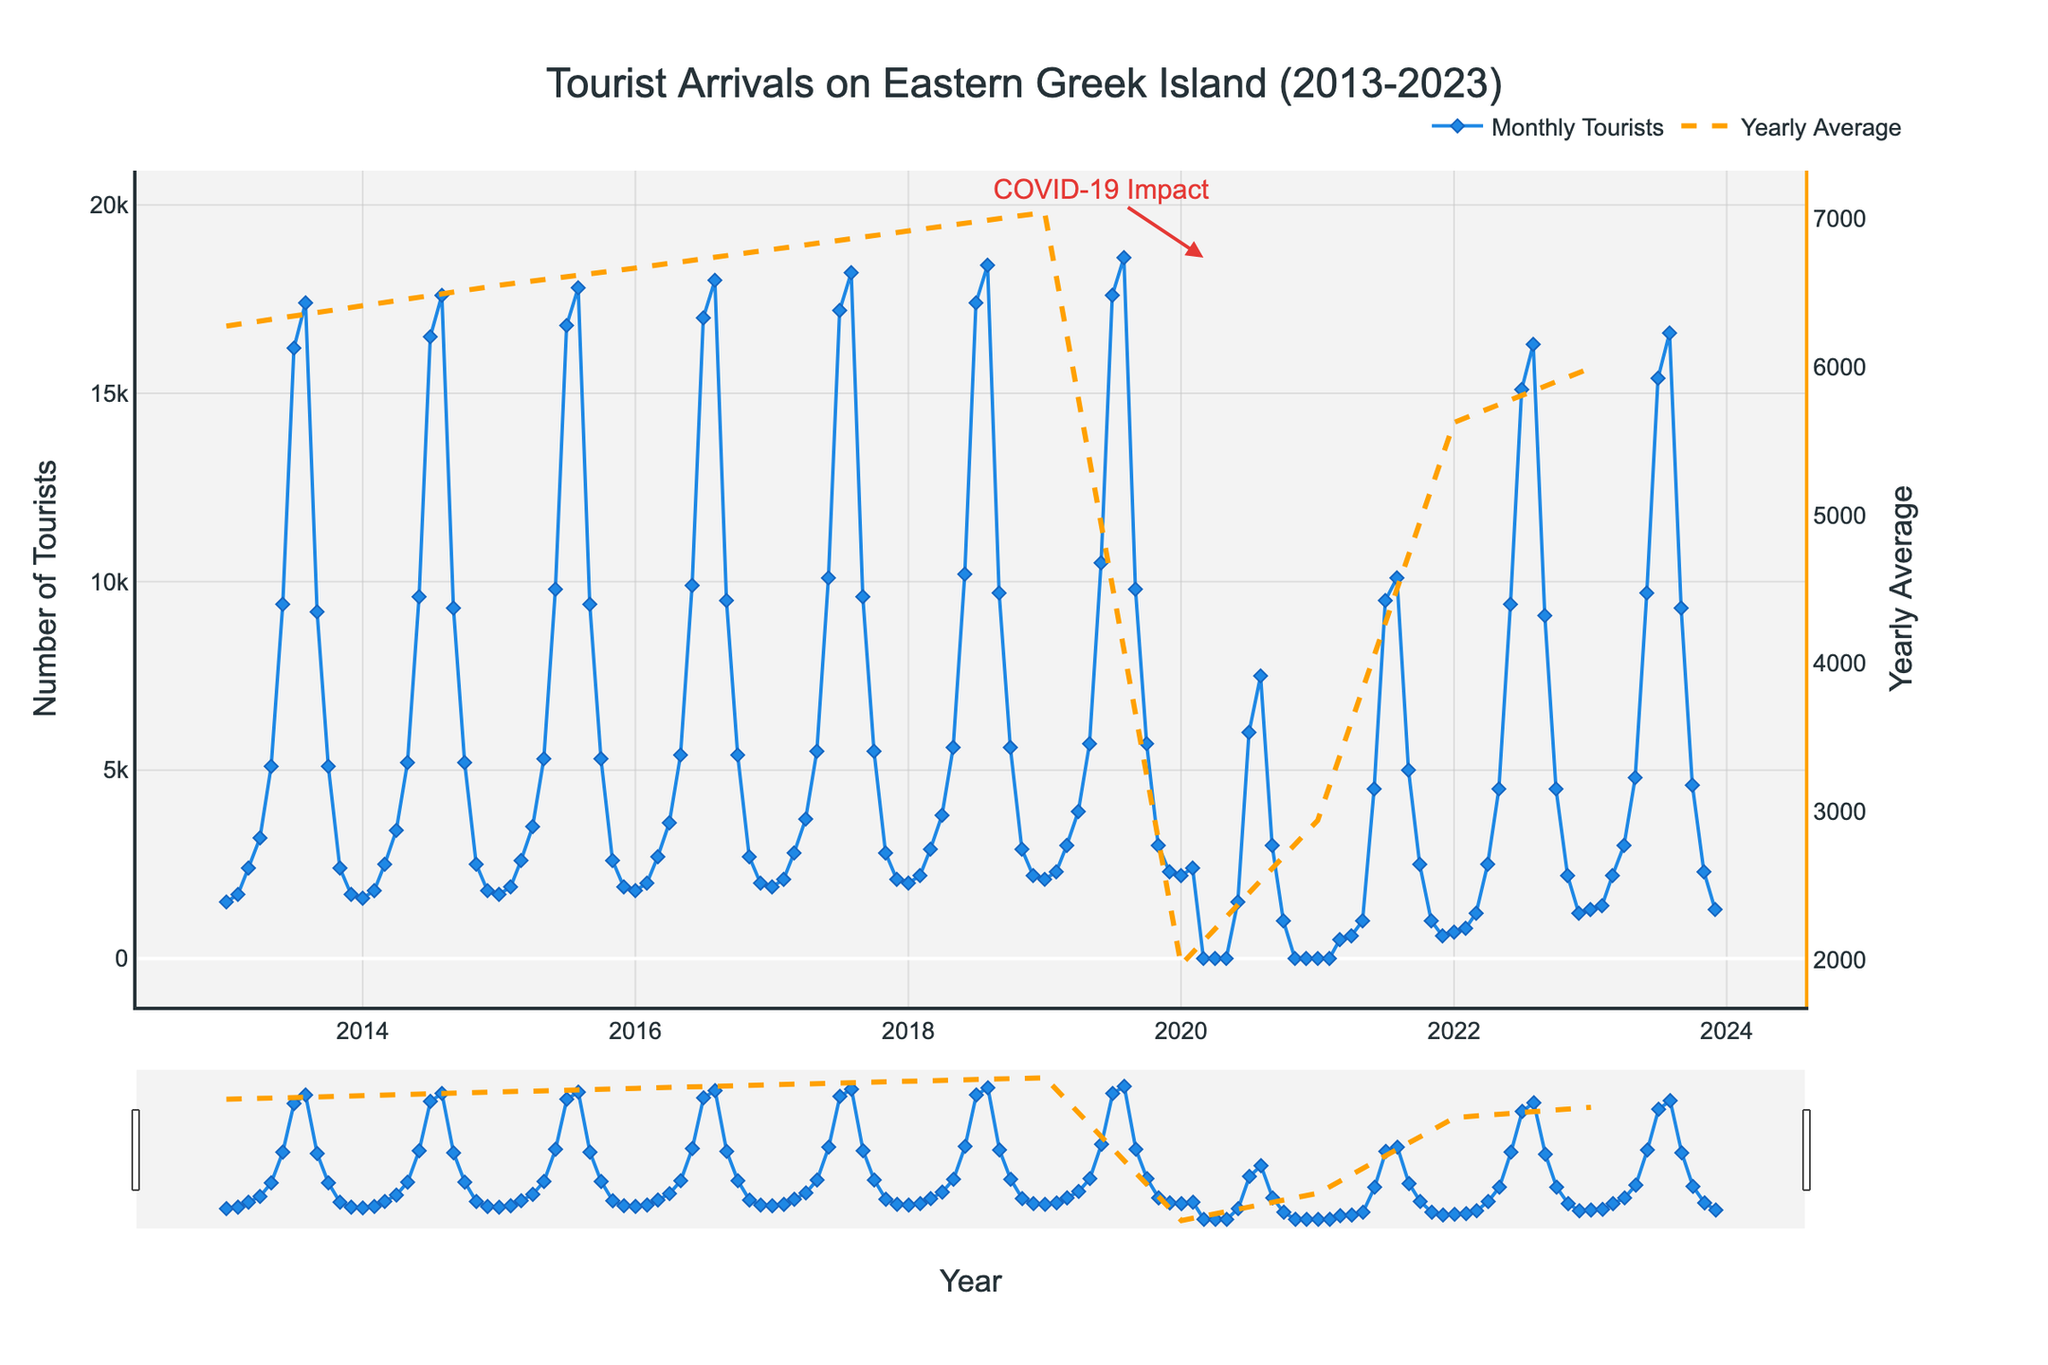What is the title of the figure? The title is usually displayed prominently at the top of the figure. In this case, it reads "Tourist Arrivals on Eastern Greek Island (2013-2023)."
Answer: Tourist Arrivals on Eastern Greek Island (2013-2023) What are the two different traces displayed in the figure? By examining the legend and the traces on the plot, we can identify two lines: one representing "Monthly Tourists" and another representing "Yearly Average" of tourist arrivals.
Answer: Monthly Tourists and Yearly Average When does the peak tourist arrival generally occur each year? The peak tourist arrival is evident by looking for the highest points in the time series for each year, which consistently occur in July and August.
Answer: July and August How did the COVID-19 pandemic affect tourist arrivals in 2020? Observing the annotation and the significant drop in tourist numbers starting from March 2020, it is evident that COVID-19 had a severe impact, causing the tourist arrival numbers to plummet to almost zero at various points in 2020.
Answer: Significant drop starting March 2020 What months typically have the lowest tourist arrivals? Analyzing the entire time series plot, the lowest tourist arrivals generally occur in the winter months, particularly in January and February.
Answer: January and February Compare the tourist arrival numbers in July 2019 to July 2020. Viewing the figure, we can see that in July 2019, the tourist number was significantly high, in contrast to July 2020, where the number dropped sharply due to the pandemic.
Answer: Much higher in 2019 than in 2020 How did the recovery of tourist arrivals look in 2021 compared to 2020? From the plot, 2021 shows a gradual increase in tourist numbers starting from very low values, reaching a peak but still lower than pre-pandemic values in 2019. The recovery is visible but incomplete.
Answer: Gradual increase but lower than 2019 What is the trend in tourist arrivals from 2013 to 2019? Observing the first part of the timeline up to 2019, the overall trend shows a steady increase in tourist arrivals with seasonal peaks each summer.
Answer: Steady increase with seasonal peaks Which year had the highest yearly average number of tourists? Referring to the secondary y-axis and the dashed "Yearly Average" line, 2019 had the highest yearly average, indicating the busiest tourist year before the pandemic.
Answer: 2019 How does the number of tourists in August 2023 compare to August 2017? By looking at the plot points for August of the respective years, August 2023 shows a slightly lower number of tourists than August 2017.
Answer: Slightly lower in 2023 than in 2017 